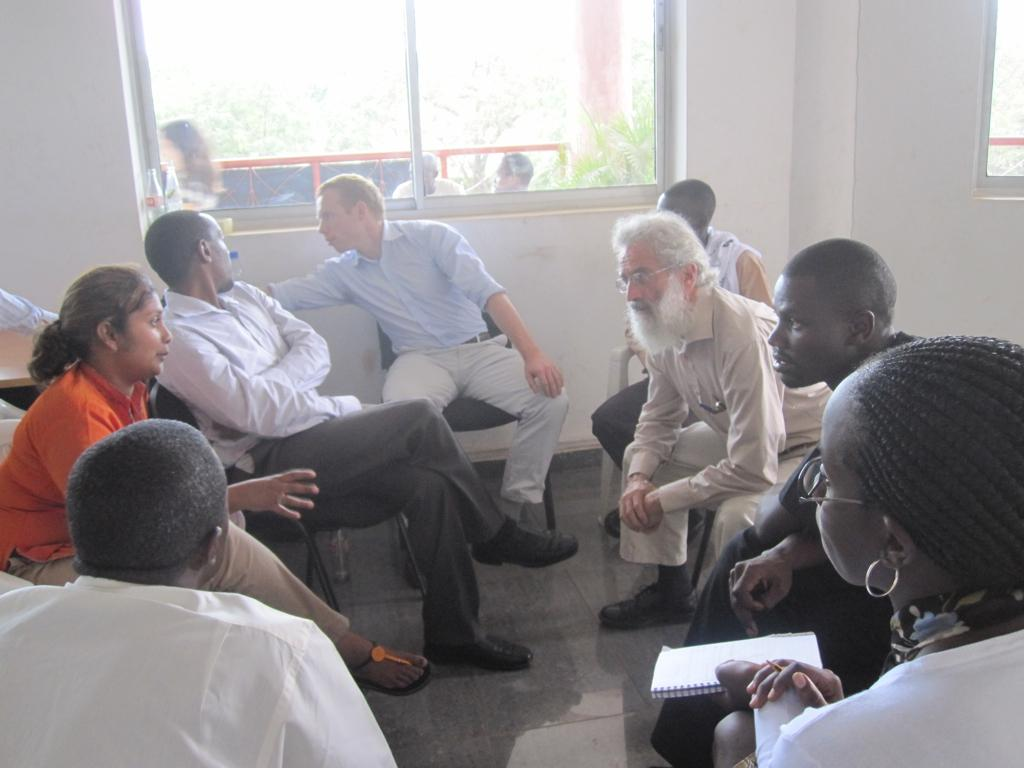How many people are in the image? There is a group of persons in the image. What are the people doing in the image? The persons are sitting on chairs and on the floor. What is the background of the image? There is a wall in the image, and through the window, persons and trees are visible. What is the condition of the wall in the image? There is a window in the wall. What can be seen through the window? Persons, trees, and a fence are visible through the window. What type of plant is growing on the club in the image? There is no club or plant present in the image. What time of day is it in the image, given the morning light? The time of day is not mentioned in the image, and there is no indication of morning light. 